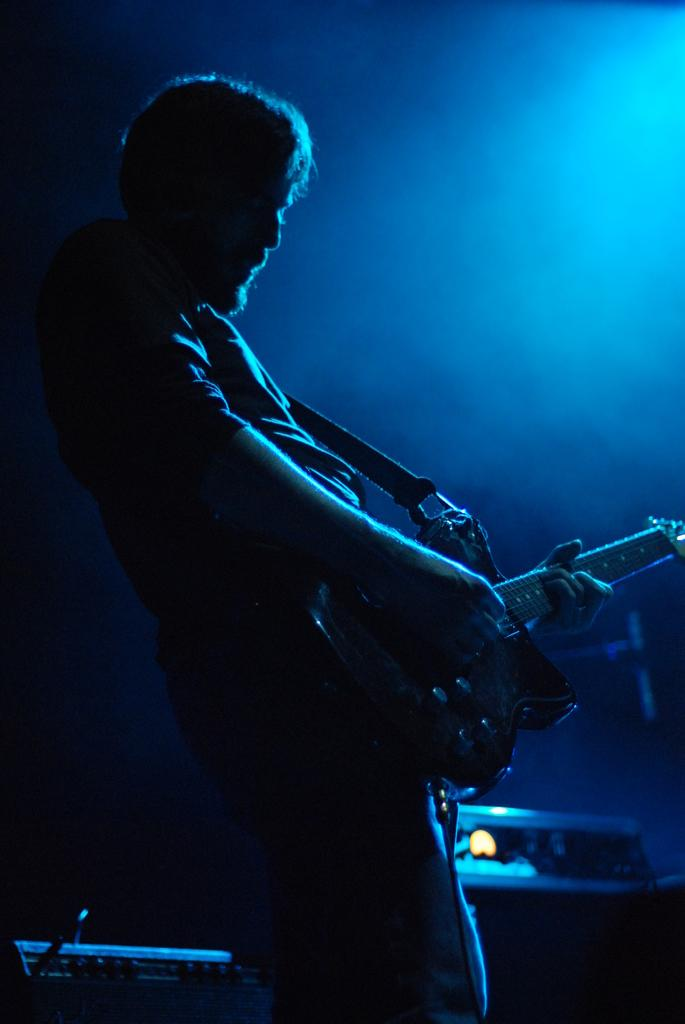What is the person in the image doing? The person in the image is playing guitar. What can be seen in the background of the image? There are objects in the background of the image. What color is the background of the image? The background of the image is blue. How does the banana contribute to the person's growth in the image? There is no banana present in the image, so it cannot contribute to the person's growth. 